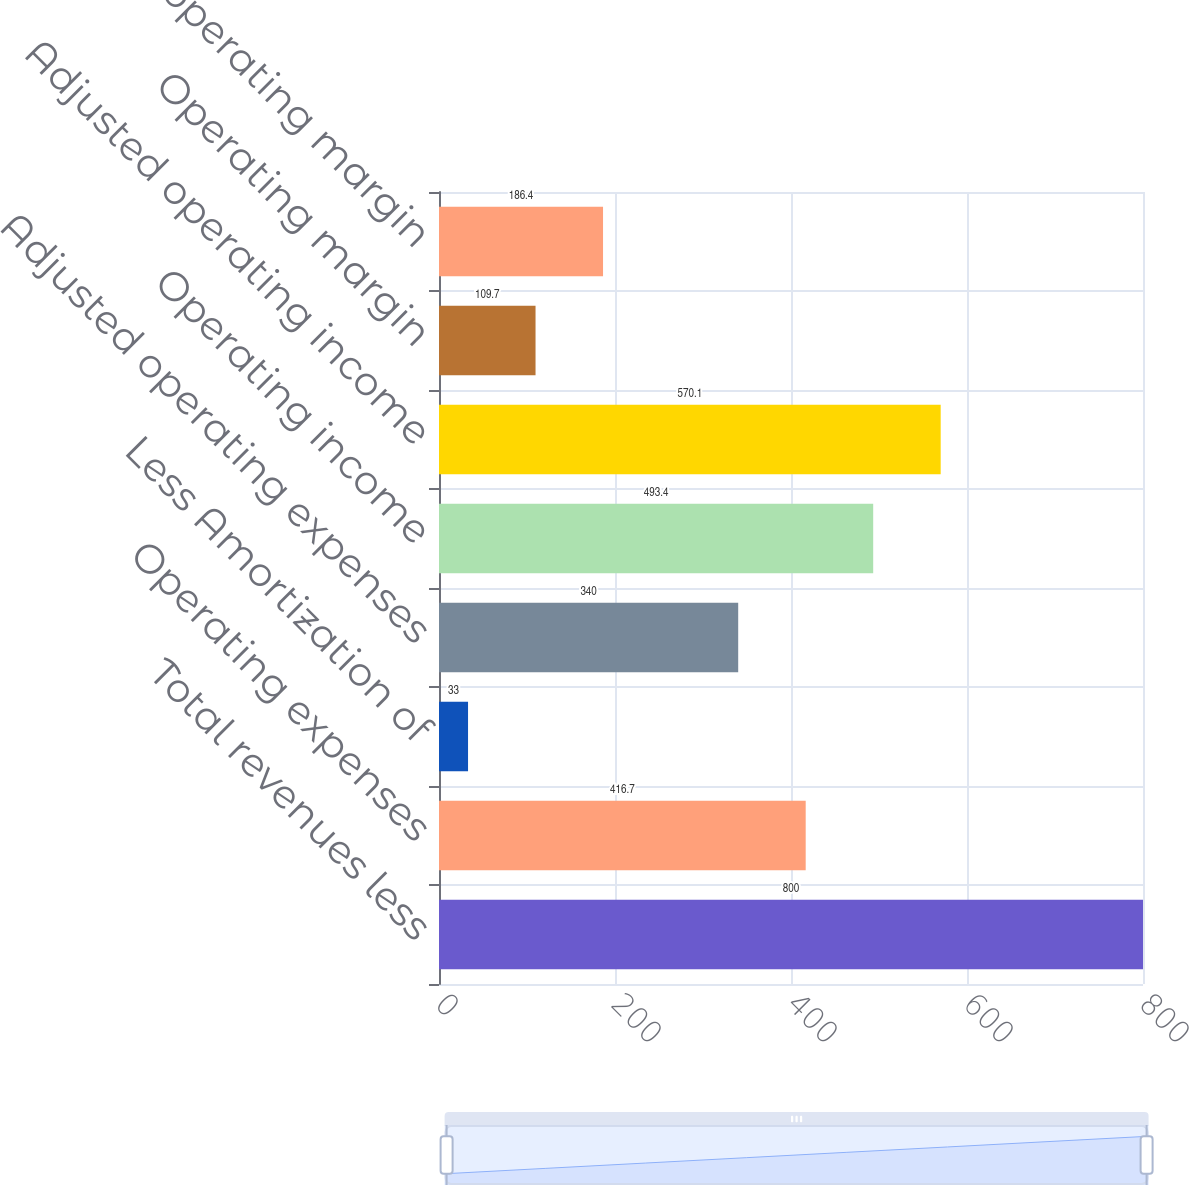Convert chart to OTSL. <chart><loc_0><loc_0><loc_500><loc_500><bar_chart><fcel>Total revenues less<fcel>Operating expenses<fcel>Less Amortization of<fcel>Adjusted operating expenses<fcel>Operating income<fcel>Adjusted operating income<fcel>Operating margin<fcel>Adjusted operating margin<nl><fcel>800<fcel>416.7<fcel>33<fcel>340<fcel>493.4<fcel>570.1<fcel>109.7<fcel>186.4<nl></chart> 